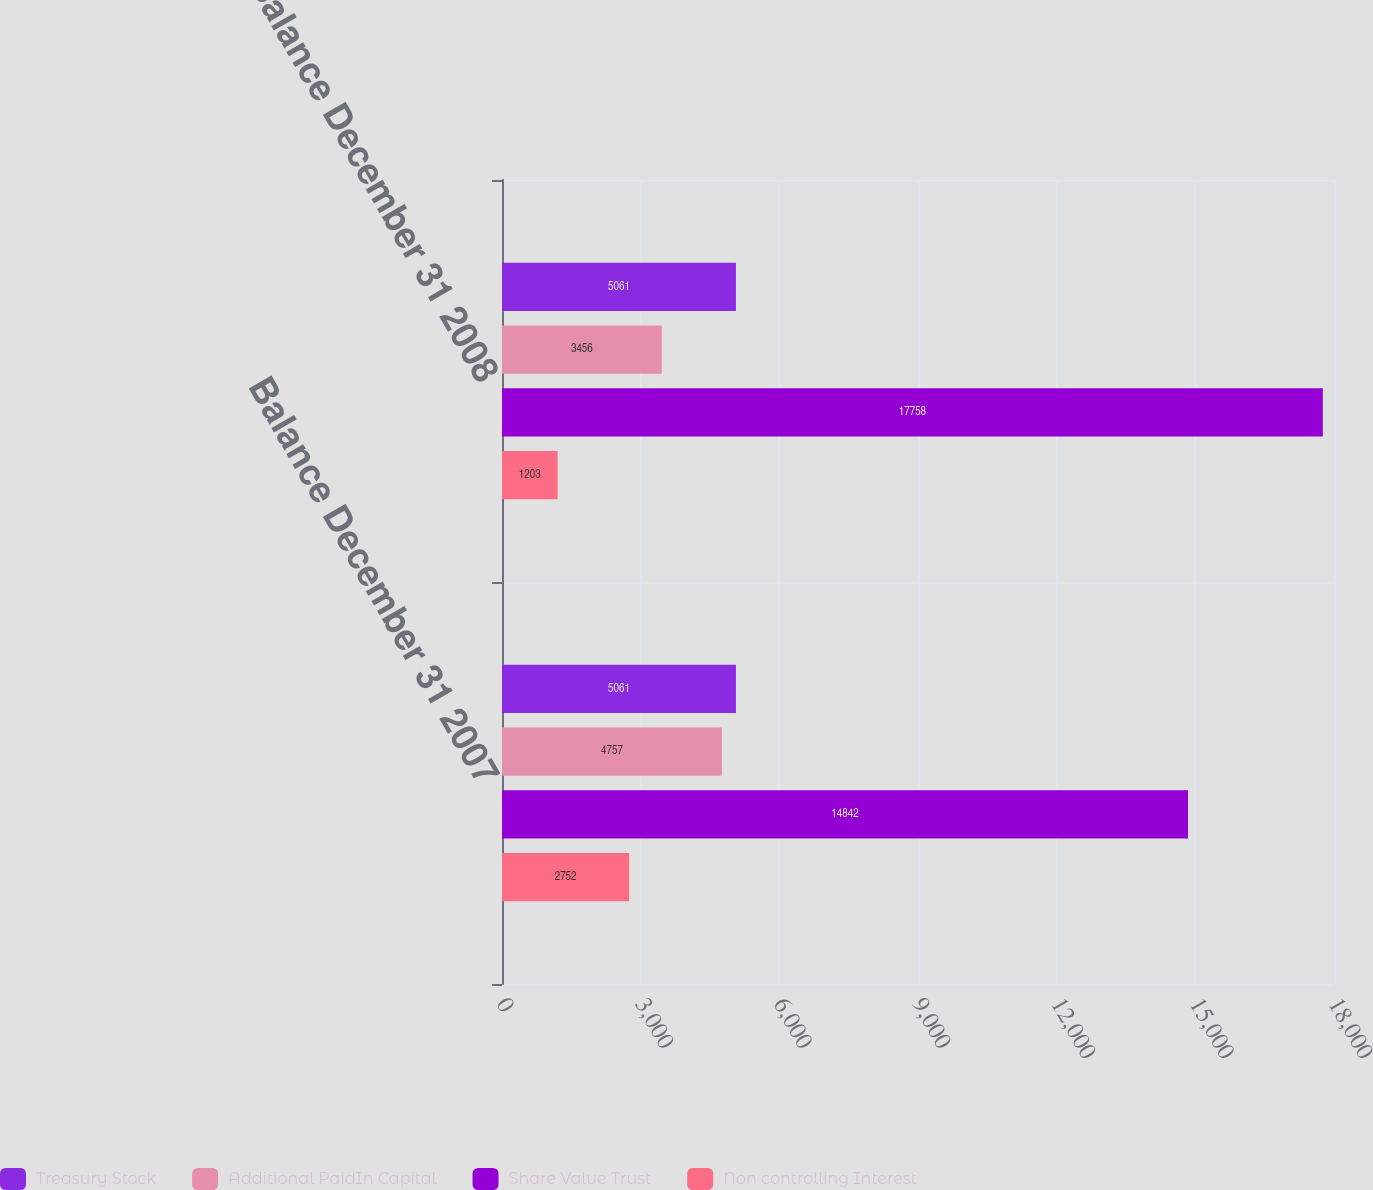Convert chart to OTSL. <chart><loc_0><loc_0><loc_500><loc_500><stacked_bar_chart><ecel><fcel>Balance December 31 2007<fcel>Balance December 31 2008<nl><fcel>Treasury Stock<fcel>5061<fcel>5061<nl><fcel>Additional PaidIn Capital<fcel>4757<fcel>3456<nl><fcel>Share Value Trust<fcel>14842<fcel>17758<nl><fcel>Non controlling Interest<fcel>2752<fcel>1203<nl></chart> 